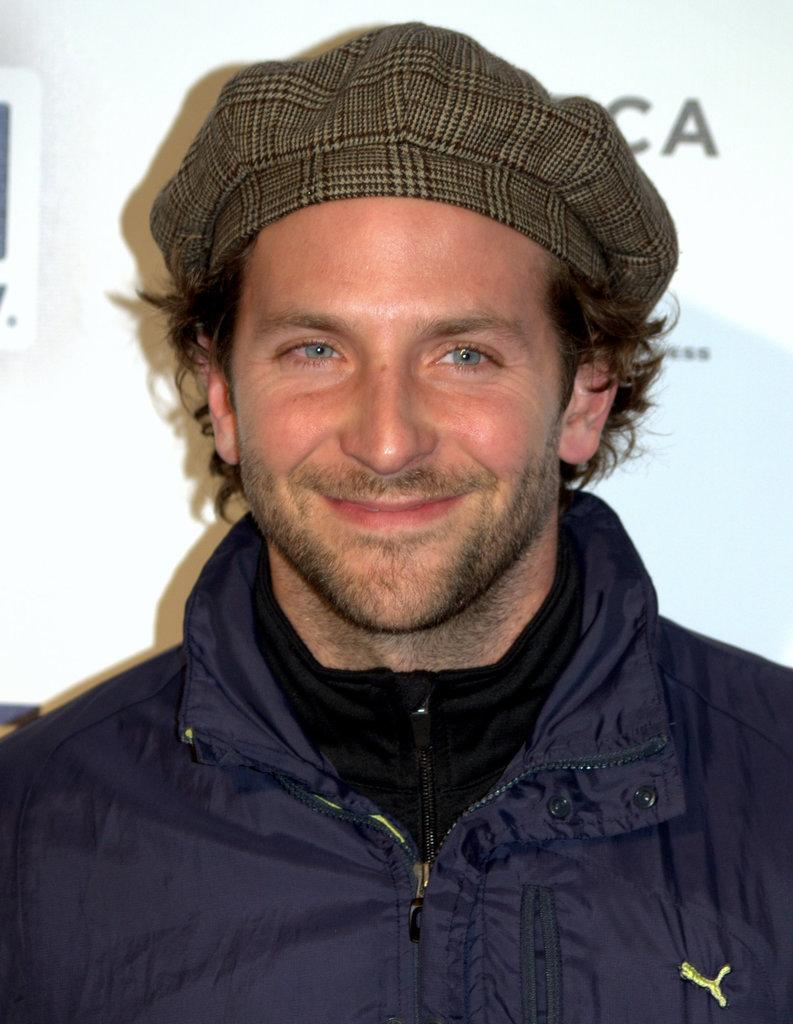Who or what is the main subject in the image? There is a person in the image. What is the person wearing on their upper body? The person is wearing a blue color jacket. What is the person's facial expression in the image? The person is smiling. What type of headwear is the person wearing? The person is wearing a cap. What color is the background of the image? The background of the image is white. What type of flower is the person holding in the image? There is no flower present in the image; the person is not holding anything. 